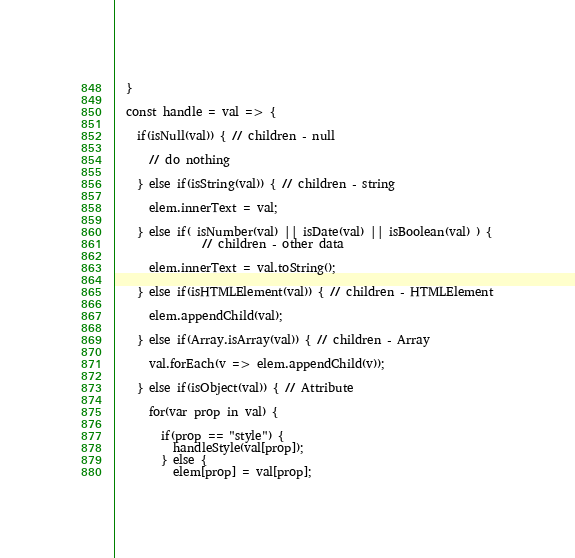<code> <loc_0><loc_0><loc_500><loc_500><_JavaScript_>  }

  const handle = val => {

    if(isNull(val)) { // children - null

      // do nothing

    } else if(isString(val)) { // children - string

      elem.innerText = val;

    } else if( isNumber(val) || isDate(val) || isBoolean(val) ) {
               // children - other data

      elem.innerText = val.toString();

    } else if(isHTMLElement(val)) { // children - HTMLElement

      elem.appendChild(val);

    } else if(Array.isArray(val)) { // children - Array

      val.forEach(v => elem.appendChild(v));

    } else if(isObject(val)) { // Attribute

      for(var prop in val) {

        if(prop == "style") {
          handleStyle(val[prop]);
        } else {
          elem[prop] = val[prop];</code> 